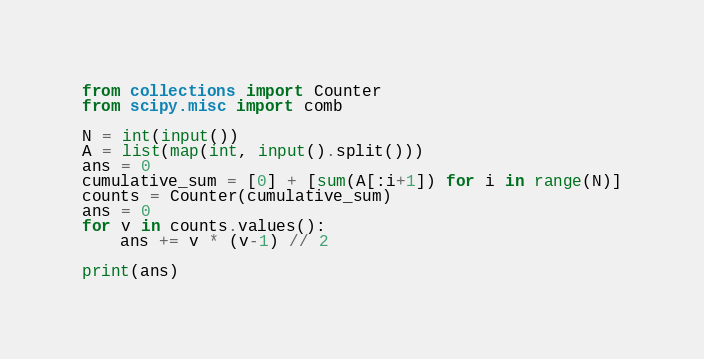Convert code to text. <code><loc_0><loc_0><loc_500><loc_500><_Python_>from collections import Counter
from scipy.misc import comb

N = int(input())
A = list(map(int, input().split()))
ans = 0
cumulative_sum = [0] + [sum(A[:i+1]) for i in range(N)]
counts = Counter(cumulative_sum)
ans = 0
for v in counts.values():
    ans += v * (v-1) // 2
    
print(ans)
</code> 